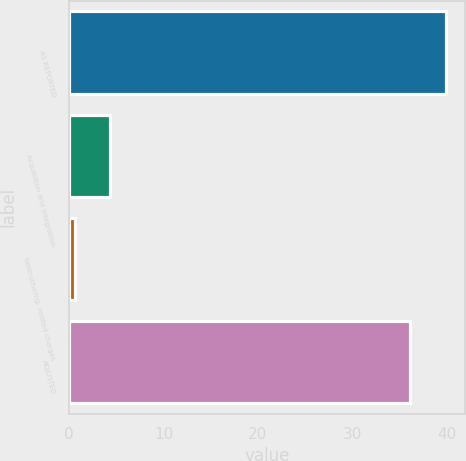<chart> <loc_0><loc_0><loc_500><loc_500><bar_chart><fcel>AS REPORTED<fcel>Acquisition and integration-<fcel>Restructuring- related charges<fcel>ADJUSTED<nl><fcel>39.88<fcel>4.38<fcel>0.6<fcel>36.1<nl></chart> 